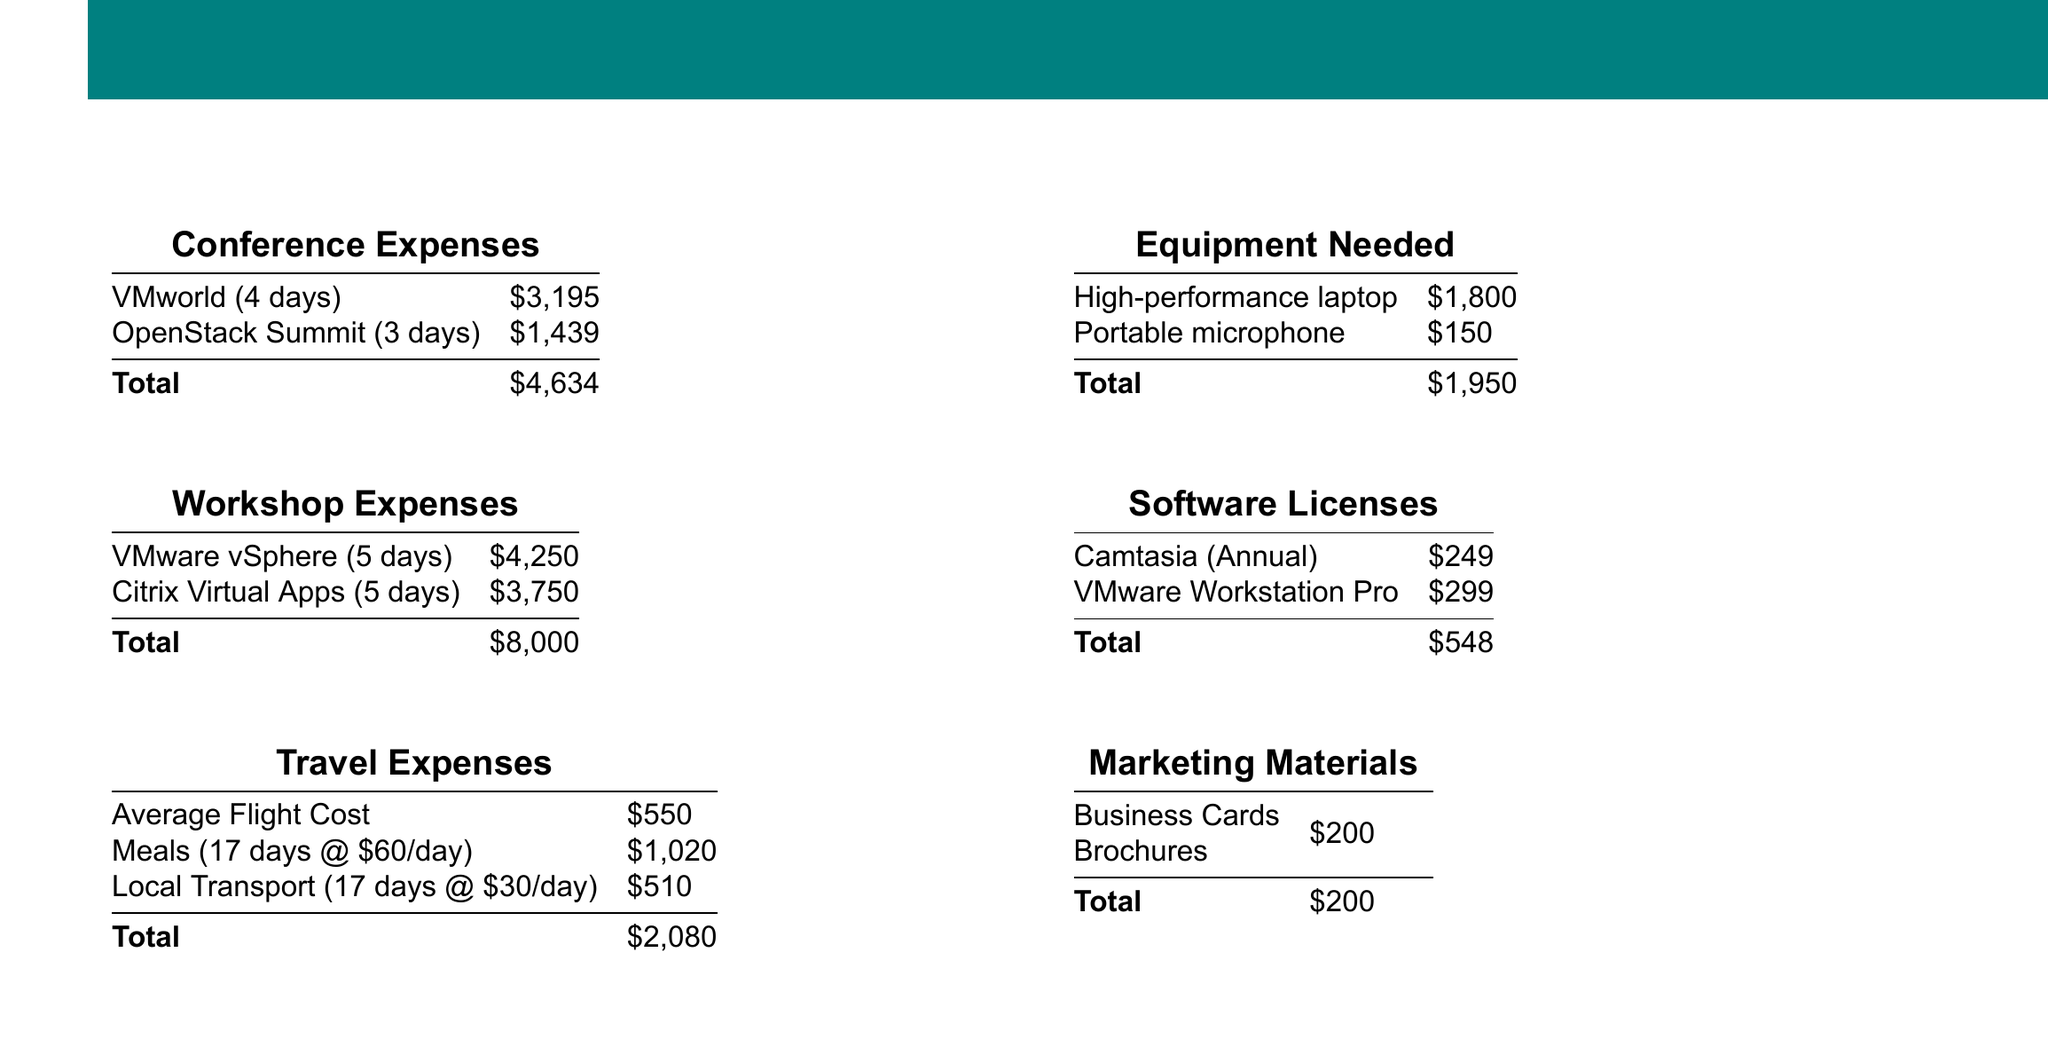what is the total cost for attending VMworld? The total cost for attending VMworld, which lasts 4 days, is listed as $3,195.
Answer: $3,195 what is the total for all conference expenses? The total for all conference expenses is obtained by adding the costs of VMworld and OpenStack Summit, which is $3,195 + $1,439.
Answer: $4,634 how much does the VMware vSphere workshop cost? The cost of the VMware vSphere workshop, which lasts 5 days, is $4,250.
Answer: $4,250 what is the total estimated budget for travel expenses? The total estimated budget for travel is calculated by adding the average flight cost, meal expenses, and local transport costs, which is $550 + $1,020 + $510.
Answer: $2,080 how much are the software licenses in total? The total for software licenses is the sum of Camtasia and VMware Workstation Pro, which is $249 + $299.
Answer: $548 which expenses are categorized under Equipment Needed? Equipment Needed includes a high-performance laptop and a portable microphone, which are $1,800 and $150 respectively.
Answer: High-performance laptop, Portable microphone what is the grand total of all expenses? The grand total of all expenses is calculated by summing all categories, which equals $4,634 + $8,000 + $2,080 + $1,950 + $548 + $200.
Answer: $17,412 how much do business cards cost as part of marketing materials? The cost of business cards, listed under marketing materials, is $200.
Answer: $200 what is the total cost for workshops? The total cost for workshops is the sum of VMware vSphere and Citrix Virtual Apps, which is $4,250 + $3,750.
Answer: $8,000 